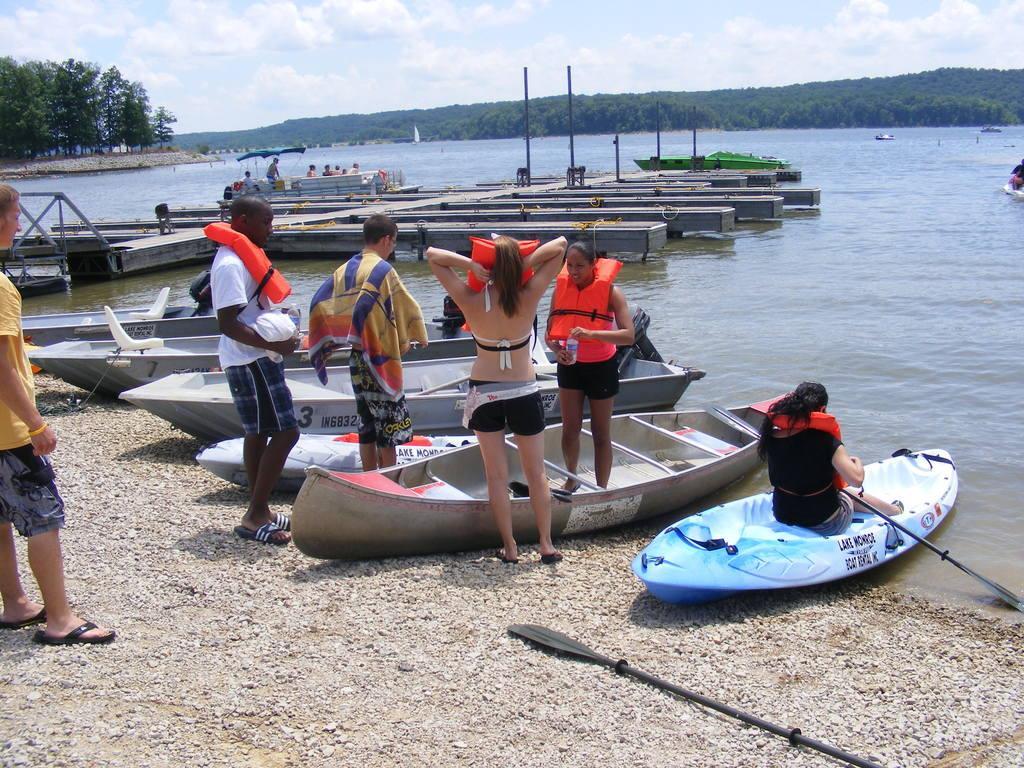In one or two sentences, can you explain what this image depicts? In this picture I can see there are few skiffs placed on the left side and there is a sea at right side, there are few trees, a mountain covered with trees and the sky is clear. 